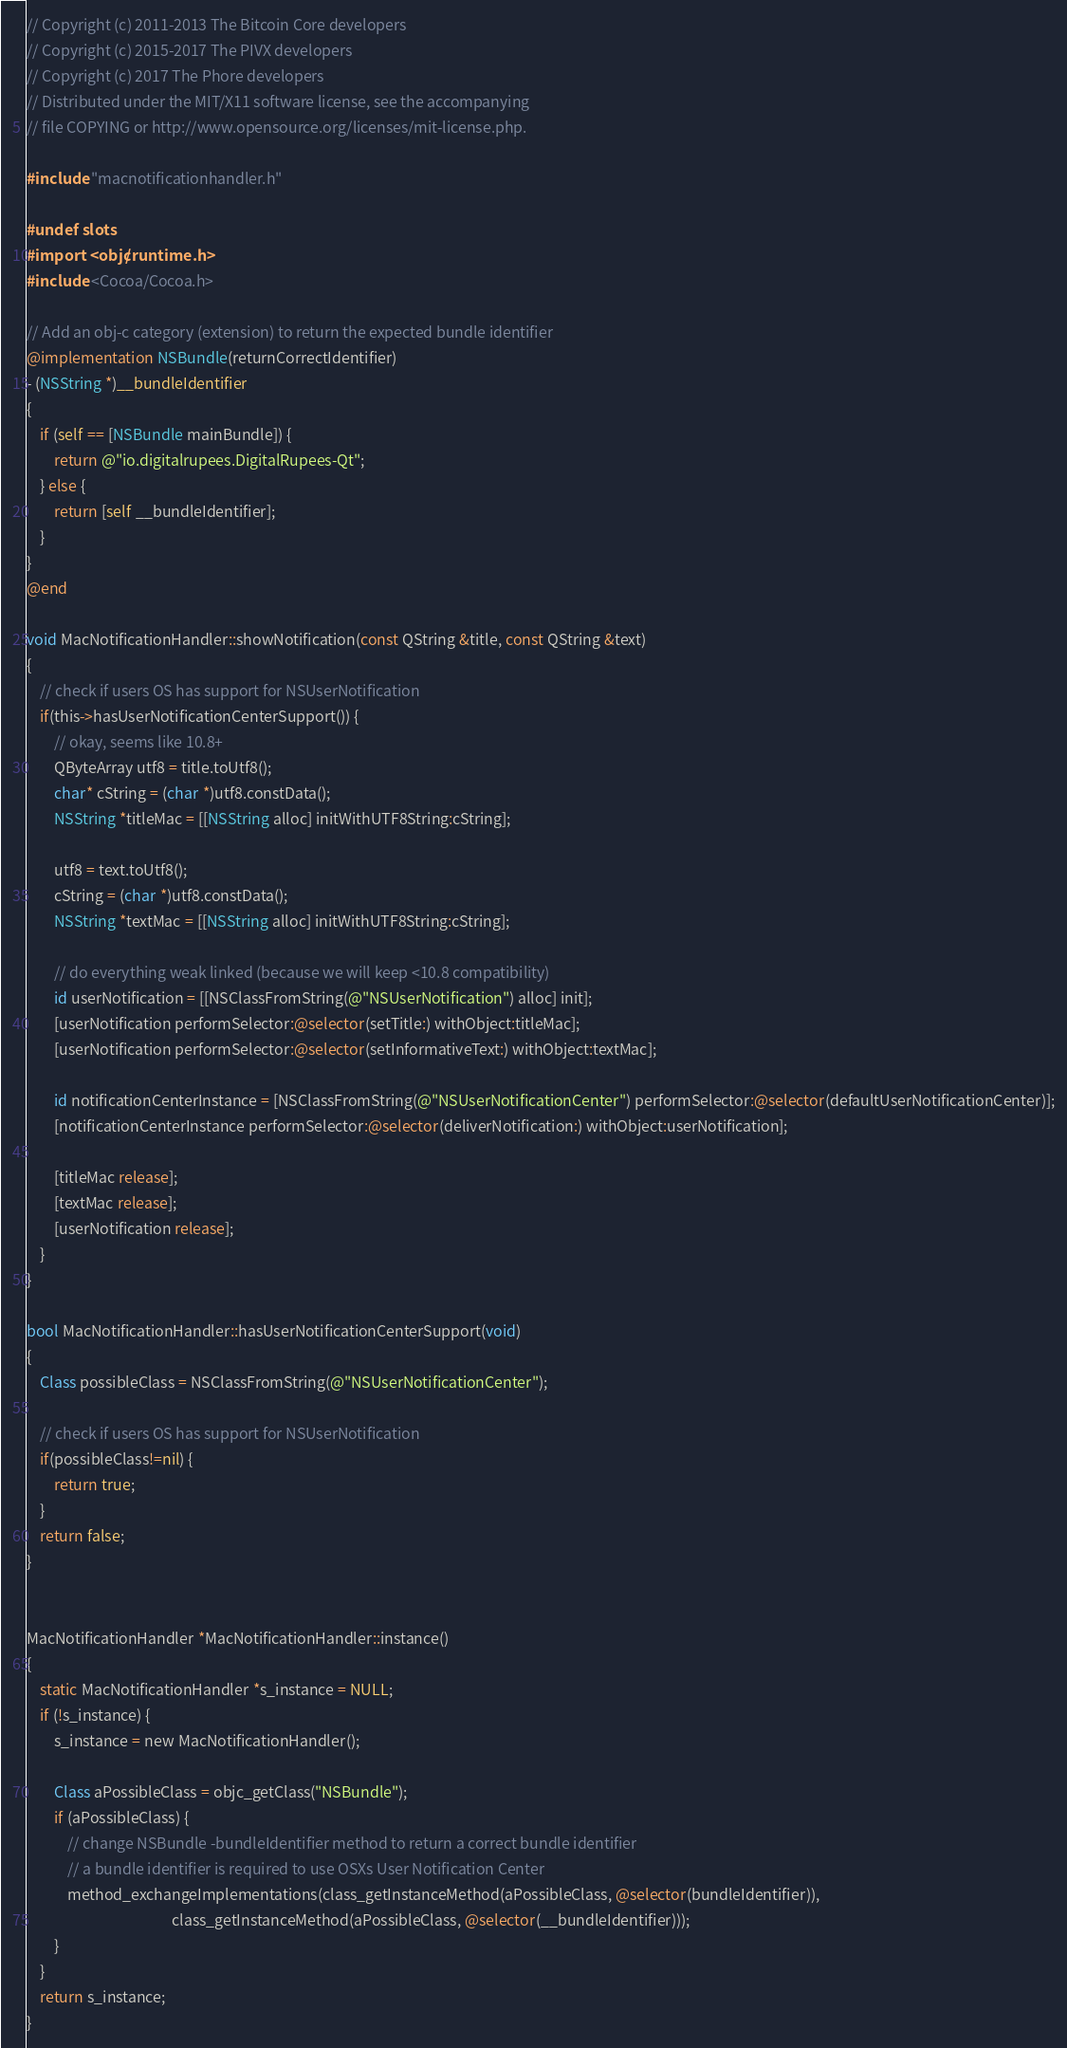Convert code to text. <code><loc_0><loc_0><loc_500><loc_500><_ObjectiveC_>// Copyright (c) 2011-2013 The Bitcoin Core developers
// Copyright (c) 2015-2017 The PIVX developers
// Copyright (c) 2017 The Phore developers
// Distributed under the MIT/X11 software license, see the accompanying
// file COPYING or http://www.opensource.org/licenses/mit-license.php.

#include "macnotificationhandler.h"

#undef slots
#import <objc/runtime.h>
#include <Cocoa/Cocoa.h>

// Add an obj-c category (extension) to return the expected bundle identifier
@implementation NSBundle(returnCorrectIdentifier)
- (NSString *)__bundleIdentifier
{
    if (self == [NSBundle mainBundle]) {
        return @"io.digitalrupees.DigitalRupees-Qt";
    } else {
        return [self __bundleIdentifier];
    }
}
@end

void MacNotificationHandler::showNotification(const QString &title, const QString &text)
{
    // check if users OS has support for NSUserNotification
    if(this->hasUserNotificationCenterSupport()) {
        // okay, seems like 10.8+
        QByteArray utf8 = title.toUtf8();
        char* cString = (char *)utf8.constData();
        NSString *titleMac = [[NSString alloc] initWithUTF8String:cString];

        utf8 = text.toUtf8();
        cString = (char *)utf8.constData();
        NSString *textMac = [[NSString alloc] initWithUTF8String:cString];

        // do everything weak linked (because we will keep <10.8 compatibility)
        id userNotification = [[NSClassFromString(@"NSUserNotification") alloc] init];
        [userNotification performSelector:@selector(setTitle:) withObject:titleMac];
        [userNotification performSelector:@selector(setInformativeText:) withObject:textMac];

        id notificationCenterInstance = [NSClassFromString(@"NSUserNotificationCenter") performSelector:@selector(defaultUserNotificationCenter)];
        [notificationCenterInstance performSelector:@selector(deliverNotification:) withObject:userNotification];

        [titleMac release];
        [textMac release];
        [userNotification release];
    }
}

bool MacNotificationHandler::hasUserNotificationCenterSupport(void)
{
    Class possibleClass = NSClassFromString(@"NSUserNotificationCenter");

    // check if users OS has support for NSUserNotification
    if(possibleClass!=nil) {
        return true;
    }
    return false;
}


MacNotificationHandler *MacNotificationHandler::instance()
{
    static MacNotificationHandler *s_instance = NULL;
    if (!s_instance) {
        s_instance = new MacNotificationHandler();
        
        Class aPossibleClass = objc_getClass("NSBundle");
        if (aPossibleClass) {
            // change NSBundle -bundleIdentifier method to return a correct bundle identifier
            // a bundle identifier is required to use OSXs User Notification Center
            method_exchangeImplementations(class_getInstanceMethod(aPossibleClass, @selector(bundleIdentifier)),
                                           class_getInstanceMethod(aPossibleClass, @selector(__bundleIdentifier)));
        }
    }
    return s_instance;
}
</code> 